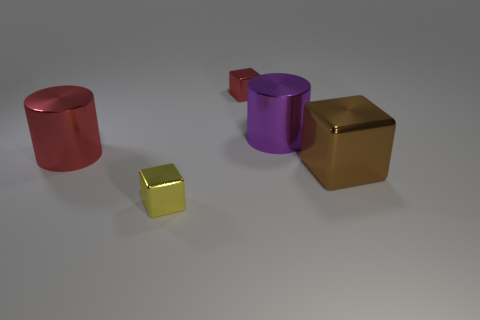Imagine these objects in a real-world scenario; what could they represent? In a real-world context, the objects could be interpreted as stylized furniture pieces, modern art installations, or even conceptual packaging designs. The variety in color and shape might suggest a collection meant to showcase diversity in design elements. 